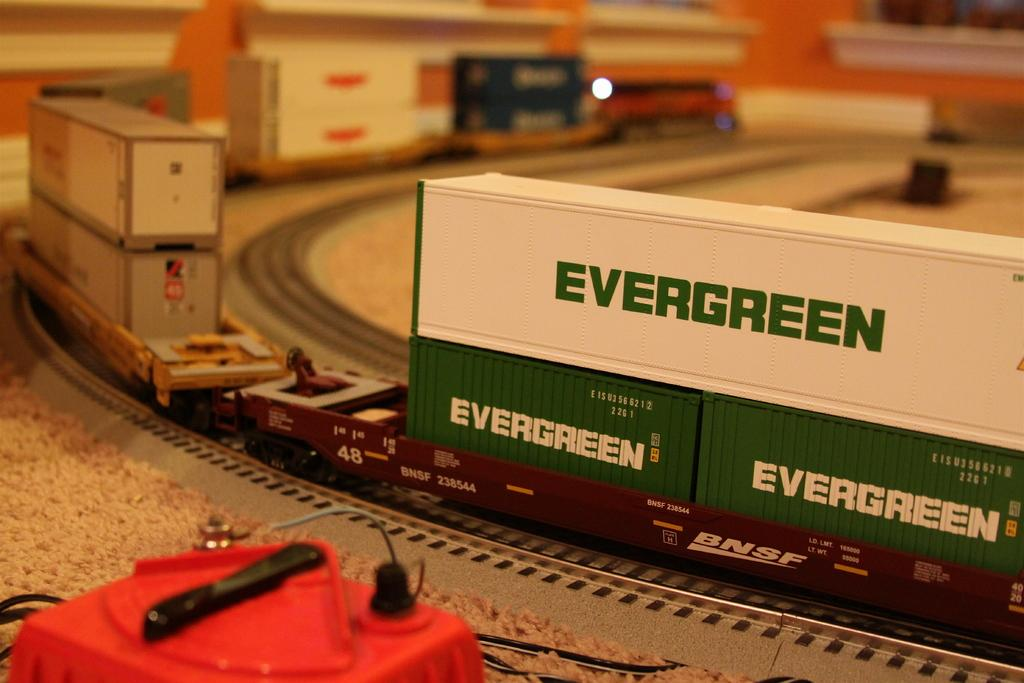<image>
Share a concise interpretation of the image provided. A model train on a track with cargo containers labeled EVERGREEN. 